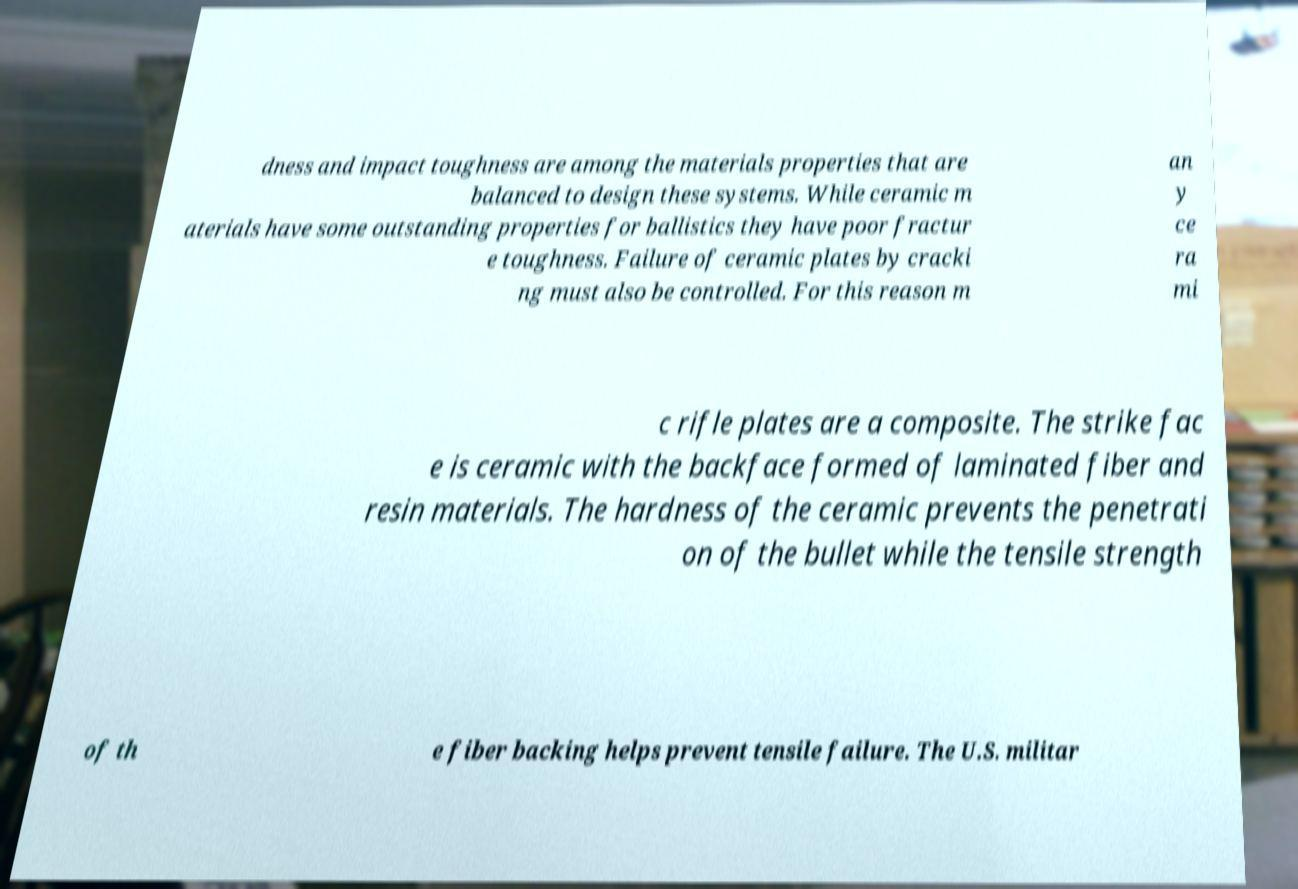Please identify and transcribe the text found in this image. dness and impact toughness are among the materials properties that are balanced to design these systems. While ceramic m aterials have some outstanding properties for ballistics they have poor fractur e toughness. Failure of ceramic plates by cracki ng must also be controlled. For this reason m an y ce ra mi c rifle plates are a composite. The strike fac e is ceramic with the backface formed of laminated fiber and resin materials. The hardness of the ceramic prevents the penetrati on of the bullet while the tensile strength of th e fiber backing helps prevent tensile failure. The U.S. militar 